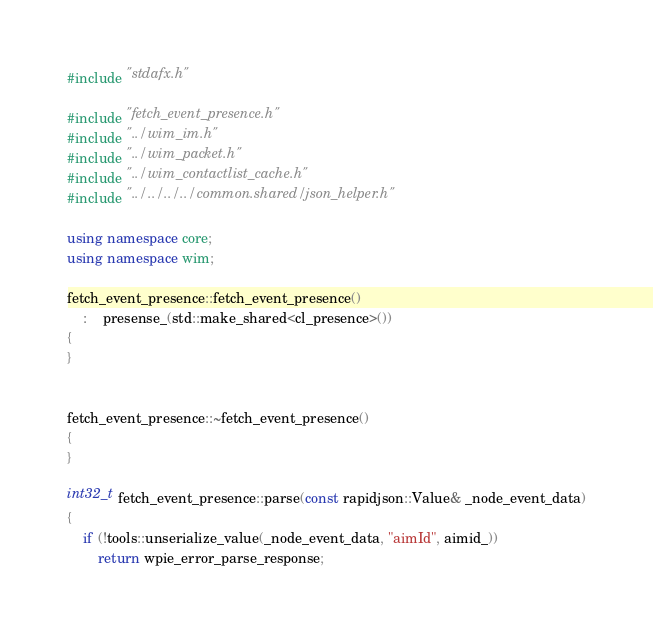<code> <loc_0><loc_0><loc_500><loc_500><_C++_>#include "stdafx.h"

#include "fetch_event_presence.h"
#include "../wim_im.h"
#include "../wim_packet.h"
#include "../wim_contactlist_cache.h"
#include "../../../../common.shared/json_helper.h"

using namespace core;
using namespace wim;

fetch_event_presence::fetch_event_presence()
    :    presense_(std::make_shared<cl_presence>())
{
}


fetch_event_presence::~fetch_event_presence()
{
}

int32_t fetch_event_presence::parse(const rapidjson::Value& _node_event_data)
{
    if (!tools::unserialize_value(_node_event_data, "aimId", aimid_))
        return wpie_error_parse_response;
</code> 